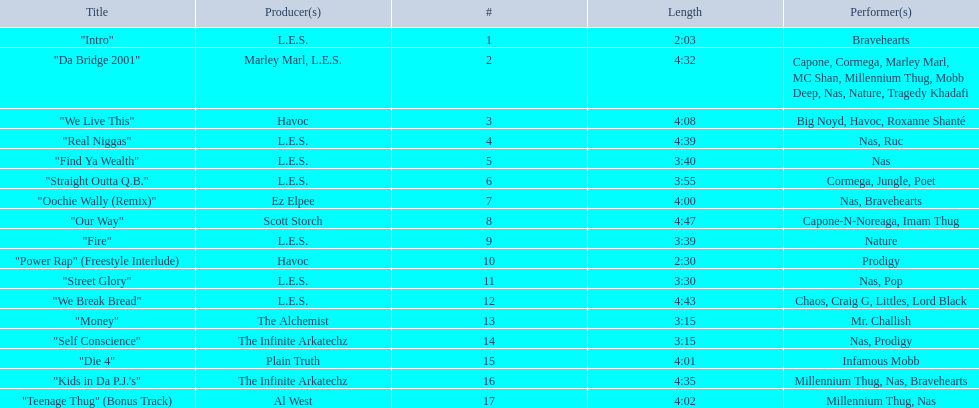How many songs are at least 4 minutes long? 9. 